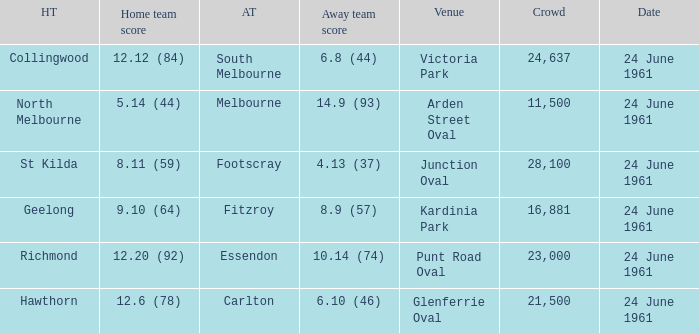Who was the home team that scored 12.6 (78)? Hawthorn. 